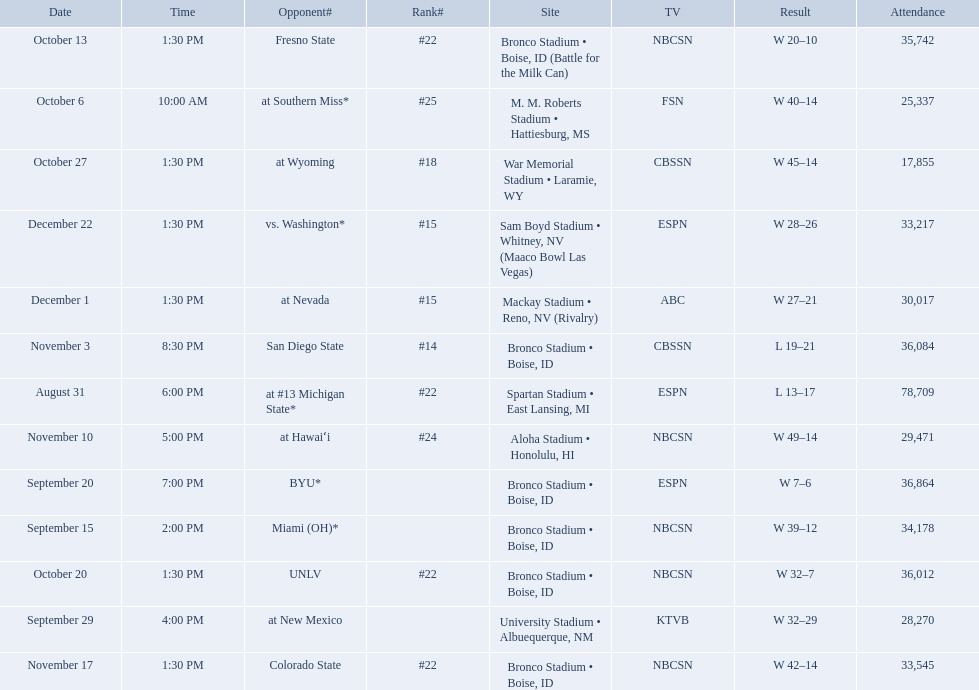Who were all of the opponents? At #13 michigan state*, miami (oh)*, byu*, at new mexico, at southern miss*, fresno state, unlv, at wyoming, san diego state, at hawaiʻi, colorado state, at nevada, vs. washington*. Who did they face on november 3rd? San Diego State. What rank were they on november 3rd? #14. 